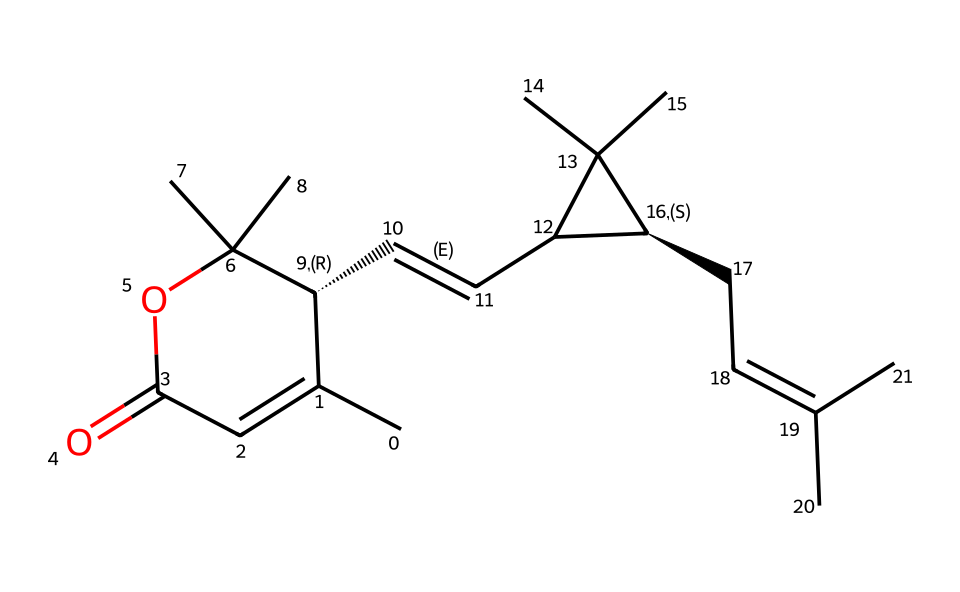how many carbon atoms are in this chemical structure? By analyzing the SMILES notation, we can count the carbon atoms. The structure contains several carbon atoms represented by 'C'. In total, there are 15 carbon atoms present in this chemical.
Answer: 15 what is the functional group present in this chemical? The chemical structure contains an ester functional group, which is indicated by the 'OC' portion of the SMILES. The 'O' atom connects to a carbon chain and a carbonyl group (C=O).
Answer: ester which part of this chemical structure is responsible for its insecticidal properties? The insecticidal properties of pyrethrins are due to the presence of the cyclopropane ring and the double bonds, which create a specific conformation to affect nerve function in insects.
Answer: cyclopropane ring how many double bonds are present in the structure? By inspecting the SMILES, we can identify the 'C=C' which shows double bonds between carbon atoms. There are a total of 3 double bonds in the structure.
Answer: 3 does this chemical structure contain any stereocenters? Yes, this chemical structure has two stereocenters indicated by the chirality notations '@' in the SMILES. This signifies that the molecule can exist in multiple stereoisomeric forms.
Answer: yes what type of molecule is pyrethrin classified as? Pyrethrin is classified as a natural insecticide, and it belongs to the class of pyrethroids, which are known for their effectiveness in pest control.
Answer: natural insecticide 